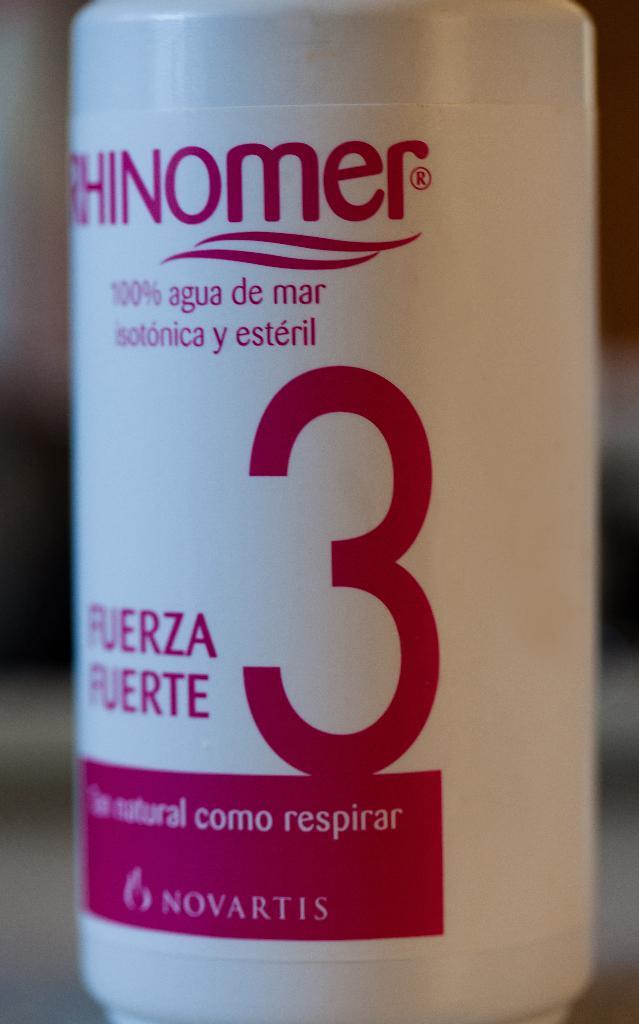What number is shown?
Give a very brief answer. 3. 